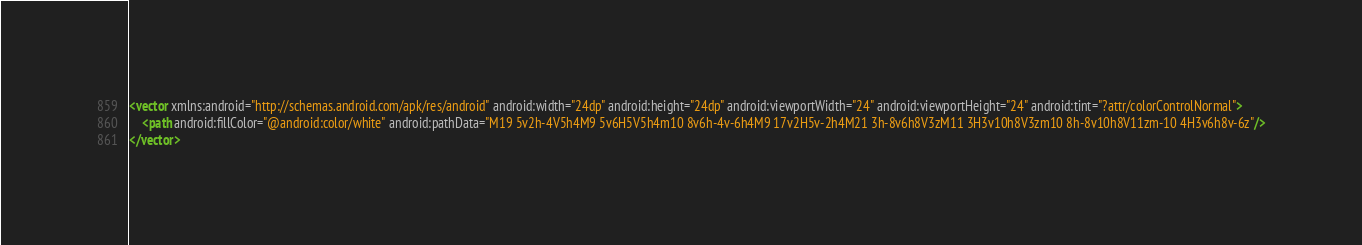Convert code to text. <code><loc_0><loc_0><loc_500><loc_500><_XML_><vector xmlns:android="http://schemas.android.com/apk/res/android" android:width="24dp" android:height="24dp" android:viewportWidth="24" android:viewportHeight="24" android:tint="?attr/colorControlNormal">
    <path android:fillColor="@android:color/white" android:pathData="M19 5v2h-4V5h4M9 5v6H5V5h4m10 8v6h-4v-6h4M9 17v2H5v-2h4M21 3h-8v6h8V3zM11 3H3v10h8V3zm10 8h-8v10h8V11zm-10 4H3v6h8v-6z"/>
</vector>
</code> 